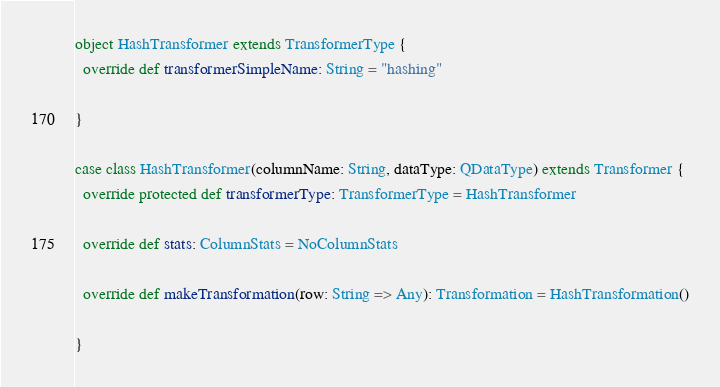<code> <loc_0><loc_0><loc_500><loc_500><_Scala_>object HashTransformer extends TransformerType {
  override def transformerSimpleName: String = "hashing"

}

case class HashTransformer(columnName: String, dataType: QDataType) extends Transformer {
  override protected def transformerType: TransformerType = HashTransformer

  override def stats: ColumnStats = NoColumnStats

  override def makeTransformation(row: String => Any): Transformation = HashTransformation()

}
</code> 